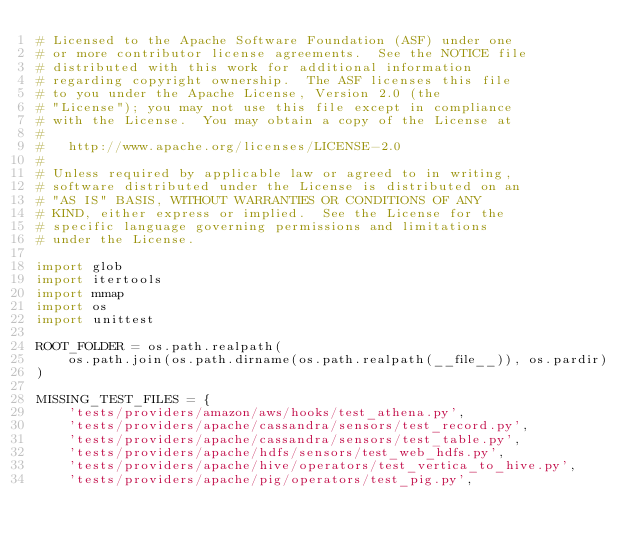<code> <loc_0><loc_0><loc_500><loc_500><_Python_># Licensed to the Apache Software Foundation (ASF) under one
# or more contributor license agreements.  See the NOTICE file
# distributed with this work for additional information
# regarding copyright ownership.  The ASF licenses this file
# to you under the Apache License, Version 2.0 (the
# "License"); you may not use this file except in compliance
# with the License.  You may obtain a copy of the License at
#
#   http://www.apache.org/licenses/LICENSE-2.0
#
# Unless required by applicable law or agreed to in writing,
# software distributed under the License is distributed on an
# "AS IS" BASIS, WITHOUT WARRANTIES OR CONDITIONS OF ANY
# KIND, either express or implied.  See the License for the
# specific language governing permissions and limitations
# under the License.

import glob
import itertools
import mmap
import os
import unittest

ROOT_FOLDER = os.path.realpath(
    os.path.join(os.path.dirname(os.path.realpath(__file__)), os.pardir)
)

MISSING_TEST_FILES = {
    'tests/providers/amazon/aws/hooks/test_athena.py',
    'tests/providers/apache/cassandra/sensors/test_record.py',
    'tests/providers/apache/cassandra/sensors/test_table.py',
    'tests/providers/apache/hdfs/sensors/test_web_hdfs.py',
    'tests/providers/apache/hive/operators/test_vertica_to_hive.py',
    'tests/providers/apache/pig/operators/test_pig.py',</code> 